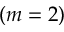<formula> <loc_0><loc_0><loc_500><loc_500>( m = 2 )</formula> 